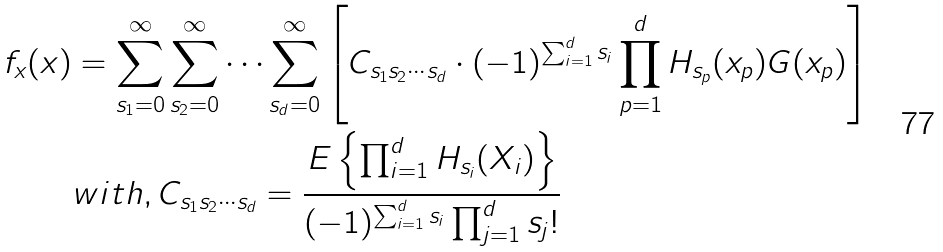<formula> <loc_0><loc_0><loc_500><loc_500>f _ { x } ( x ) & = \sum _ { s _ { 1 } = 0 } ^ { \infty } \sum _ { s _ { 2 } = 0 } ^ { \infty } \dots \sum _ { s _ { d } = 0 } ^ { \infty } \left [ C _ { s _ { 1 } s _ { 2 } \cdots s _ { d } } \cdot ( - 1 ) ^ { \sum _ { i = 1 } ^ { d } s _ { i } } \prod _ { p = 1 } ^ { d } H _ { s _ { p } } ( x _ { p } ) G ( x _ { p } ) \right ] \\ & w i t h , C _ { s _ { 1 } s _ { 2 } \cdots s _ { d } } = \frac { E \left \{ \prod _ { i = 1 } ^ { d } H _ { s _ { i } } ( X _ { i } ) \right \} } { ( - 1 ) ^ { \sum _ { i = 1 } ^ { d } s _ { i } } \prod _ { j = 1 } ^ { d } s _ { j } ! }</formula> 